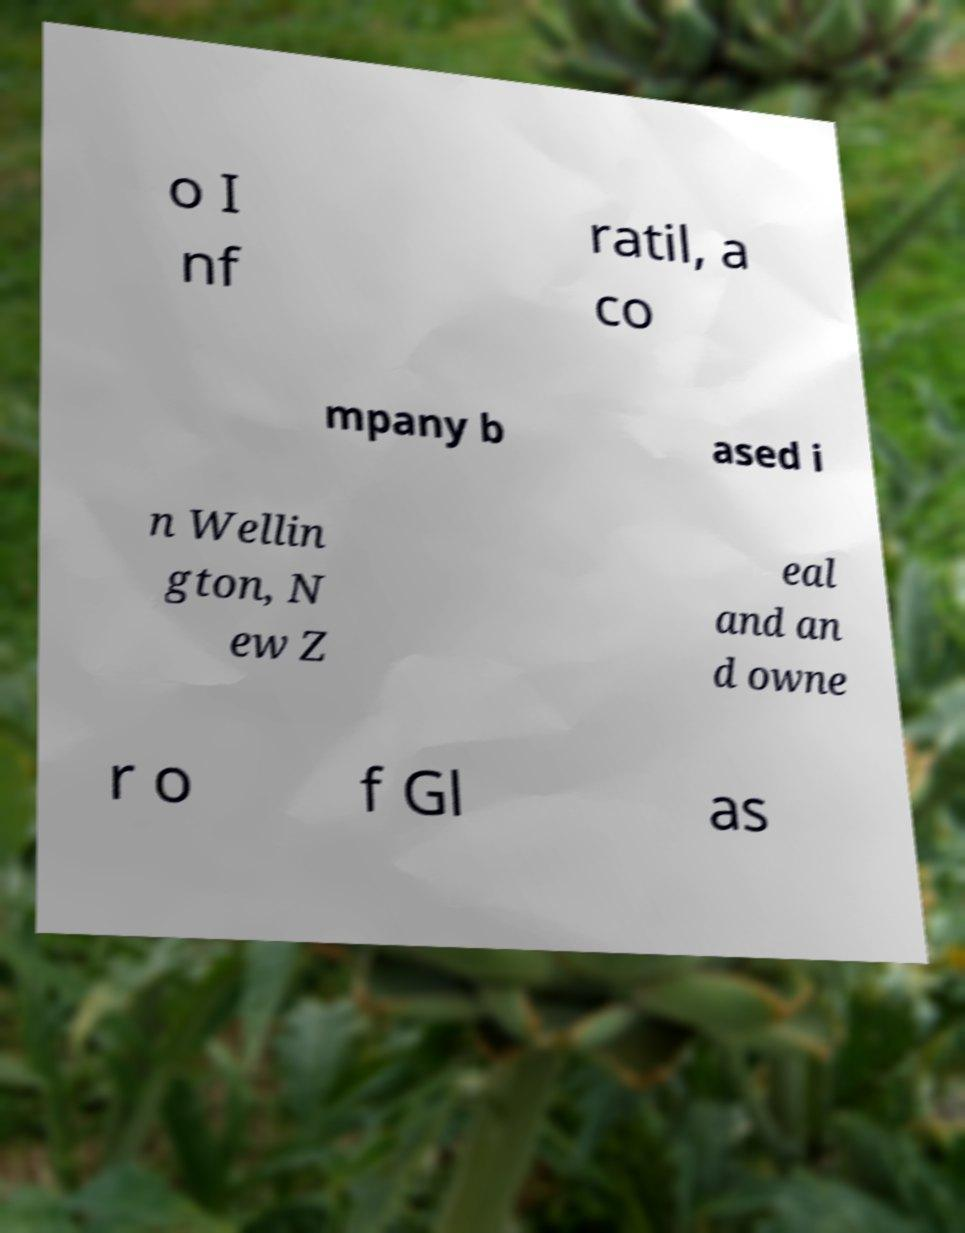Could you assist in decoding the text presented in this image and type it out clearly? o I nf ratil, a co mpany b ased i n Wellin gton, N ew Z eal and an d owne r o f Gl as 